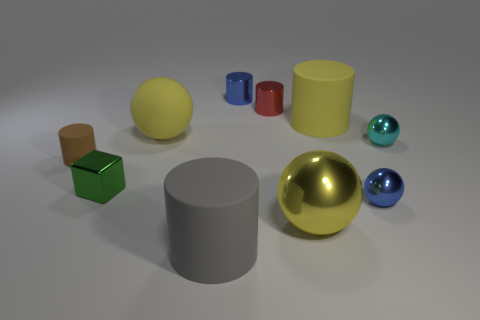Subtract all blue metallic cylinders. How many cylinders are left? 4 Subtract all red cubes. How many yellow balls are left? 2 Subtract all cyan spheres. How many spheres are left? 3 Subtract all cubes. How many objects are left? 9 Subtract 2 balls. How many balls are left? 2 Subtract all purple cylinders. Subtract all brown blocks. How many cylinders are left? 5 Subtract all tiny green metal things. Subtract all blue metal balls. How many objects are left? 8 Add 4 tiny metallic cylinders. How many tiny metallic cylinders are left? 6 Add 5 tiny red cylinders. How many tiny red cylinders exist? 6 Subtract 0 purple cubes. How many objects are left? 10 